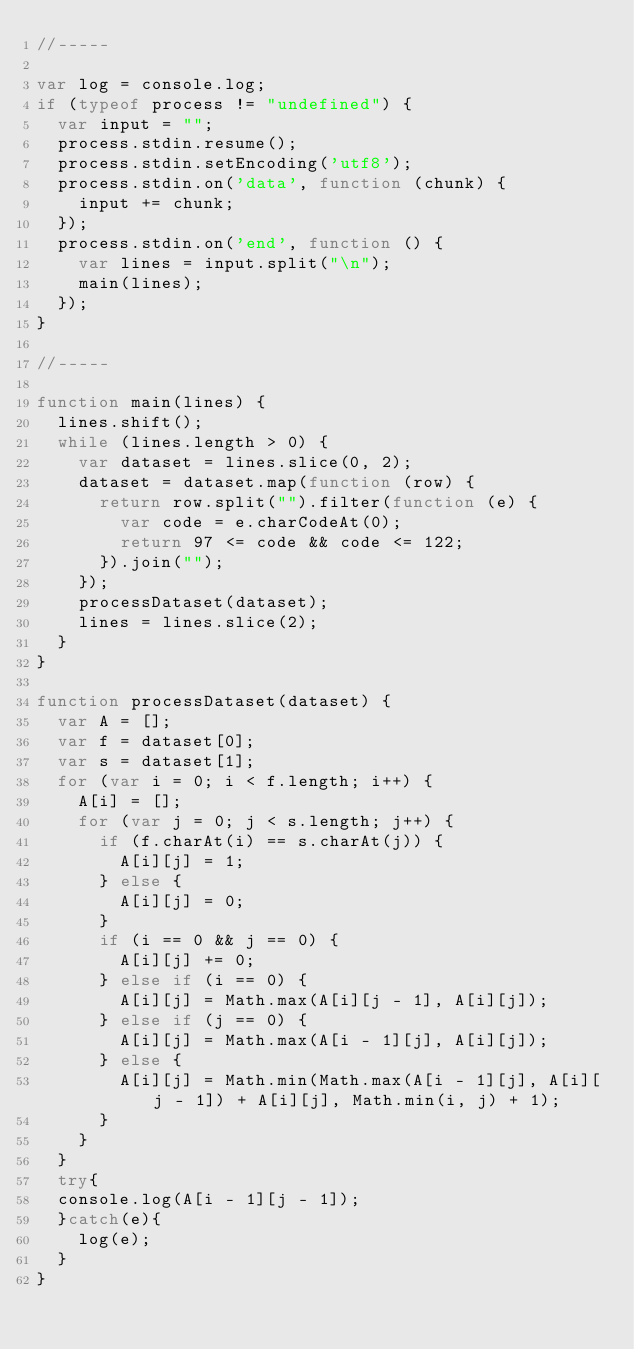<code> <loc_0><loc_0><loc_500><loc_500><_JavaScript_>//-----

var log = console.log;
if (typeof process != "undefined") {
	var input = "";
	process.stdin.resume();
	process.stdin.setEncoding('utf8');
	process.stdin.on('data', function (chunk) {
		input += chunk;
	});
	process.stdin.on('end', function () {
		var lines = input.split("\n");
		main(lines);
	});
}

//-----

function main(lines) {
	lines.shift();
	while (lines.length > 0) {
		var dataset = lines.slice(0, 2);
		dataset = dataset.map(function (row) {
			return row.split("").filter(function (e) {
				var code = e.charCodeAt(0);
				return 97 <= code && code <= 122;
			}).join("");
		});
		processDataset(dataset);
		lines = lines.slice(2);
	}
}

function processDataset(dataset) {
	var A = [];
	var f = dataset[0];
	var s = dataset[1];
	for (var i = 0; i < f.length; i++) {
		A[i] = [];
		for (var j = 0; j < s.length; j++) {
			if (f.charAt(i) == s.charAt(j)) {
				A[i][j] = 1;
			} else {
				A[i][j] = 0;
			}
			if (i == 0 && j == 0) {
				A[i][j] += 0;
			} else if (i == 0) {
				A[i][j] = Math.max(A[i][j - 1], A[i][j]);
			} else if (j == 0) {
				A[i][j] = Math.max(A[i - 1][j], A[i][j]);
			} else {
				A[i][j] = Math.min(Math.max(A[i - 1][j], A[i][j - 1]) + A[i][j], Math.min(i, j) + 1);
			}
		}
	}
	try{
	console.log(A[i - 1][j - 1]);
	}catch(e){
		log(e);
	}
}</code> 